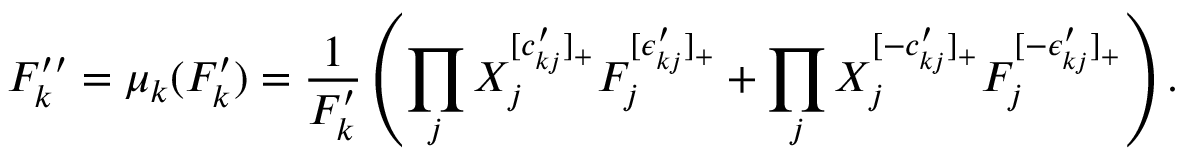Convert formula to latex. <formula><loc_0><loc_0><loc_500><loc_500>F _ { k } ^ { \prime \prime } = \mu _ { k } ( F _ { k } ^ { \prime } ) = \frac { 1 } { F _ { k } ^ { \prime } } \left ( \prod _ { j } X _ { j } ^ { [ c _ { k j } ^ { \prime } ] _ { + } } F _ { j } ^ { [ \epsilon _ { k j } ^ { \prime } ] _ { + } } + \prod _ { j } X _ { j } ^ { [ - c _ { k j } ^ { \prime } ] _ { + } } F _ { j } ^ { [ - \epsilon _ { k j } ^ { \prime } ] _ { + } } \right ) .</formula> 